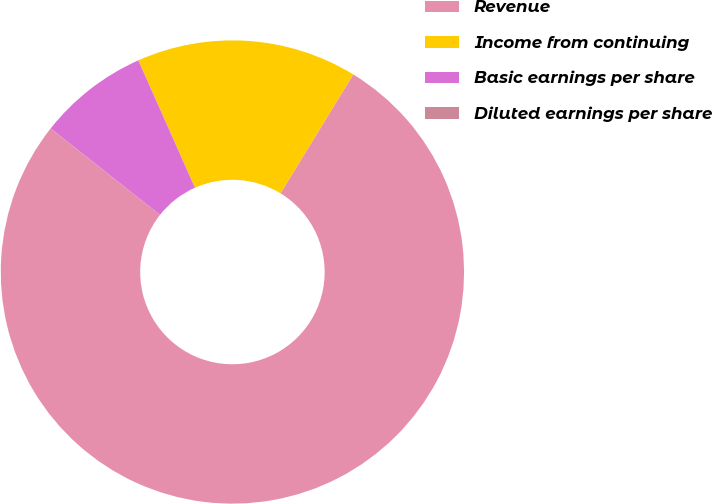Convert chart. <chart><loc_0><loc_0><loc_500><loc_500><pie_chart><fcel>Revenue<fcel>Income from continuing<fcel>Basic earnings per share<fcel>Diluted earnings per share<nl><fcel>76.9%<fcel>15.39%<fcel>7.7%<fcel>0.01%<nl></chart> 